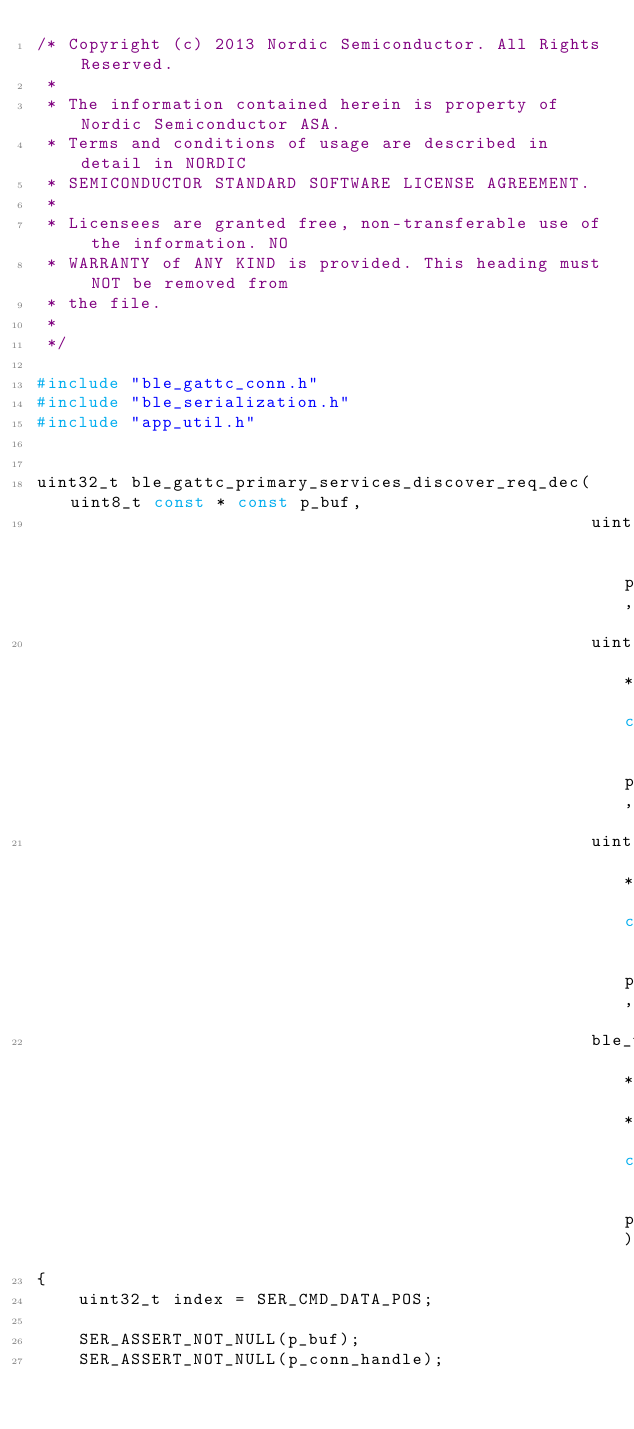Convert code to text. <code><loc_0><loc_0><loc_500><loc_500><_C_>/* Copyright (c) 2013 Nordic Semiconductor. All Rights Reserved.
 *
 * The information contained herein is property of Nordic Semiconductor ASA.
 * Terms and conditions of usage are described in detail in NORDIC
 * SEMICONDUCTOR STANDARD SOFTWARE LICENSE AGREEMENT.
 *
 * Licensees are granted free, non-transferable use of the information. NO
 * WARRANTY of ANY KIND is provided. This heading must NOT be removed from
 * the file.
 *
 */

#include "ble_gattc_conn.h"
#include "ble_serialization.h"
#include "app_util.h"


uint32_t ble_gattc_primary_services_discover_req_dec(uint8_t const * const p_buf,
                                                     uint16_t              packet_len,
                                                     uint16_t * const      p_conn_handle,
                                                     uint16_t * const      p_start_handle,
                                                     ble_uuid_t * * const  pp_srvc_uuid)
{
    uint32_t index = SER_CMD_DATA_POS;

    SER_ASSERT_NOT_NULL(p_buf);
    SER_ASSERT_NOT_NULL(p_conn_handle);</code> 